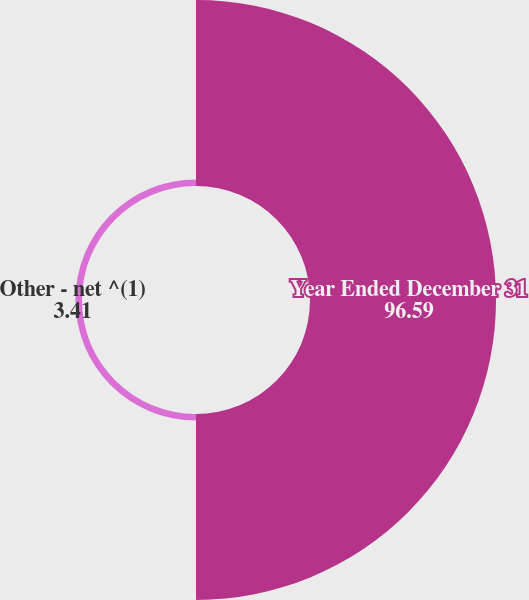Convert chart. <chart><loc_0><loc_0><loc_500><loc_500><pie_chart><fcel>Year Ended December 31<fcel>Other - net ^(1)<nl><fcel>96.59%<fcel>3.41%<nl></chart> 